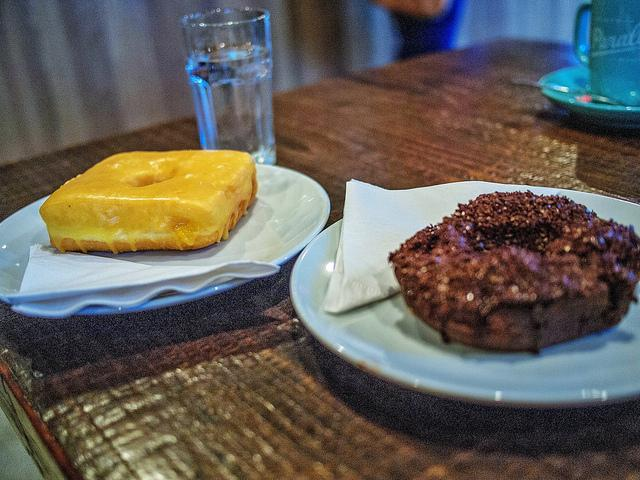What material would the plates be made of?

Choices:
A) ceramic
B) wood
C) iron
D) carpet ceramic 